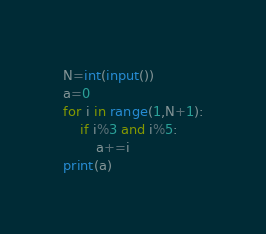Convert code to text. <code><loc_0><loc_0><loc_500><loc_500><_Python_>N=int(input())
a=0
for i in range(1,N+1):
    if i%3 and i%5:
        a+=i
print(a)</code> 